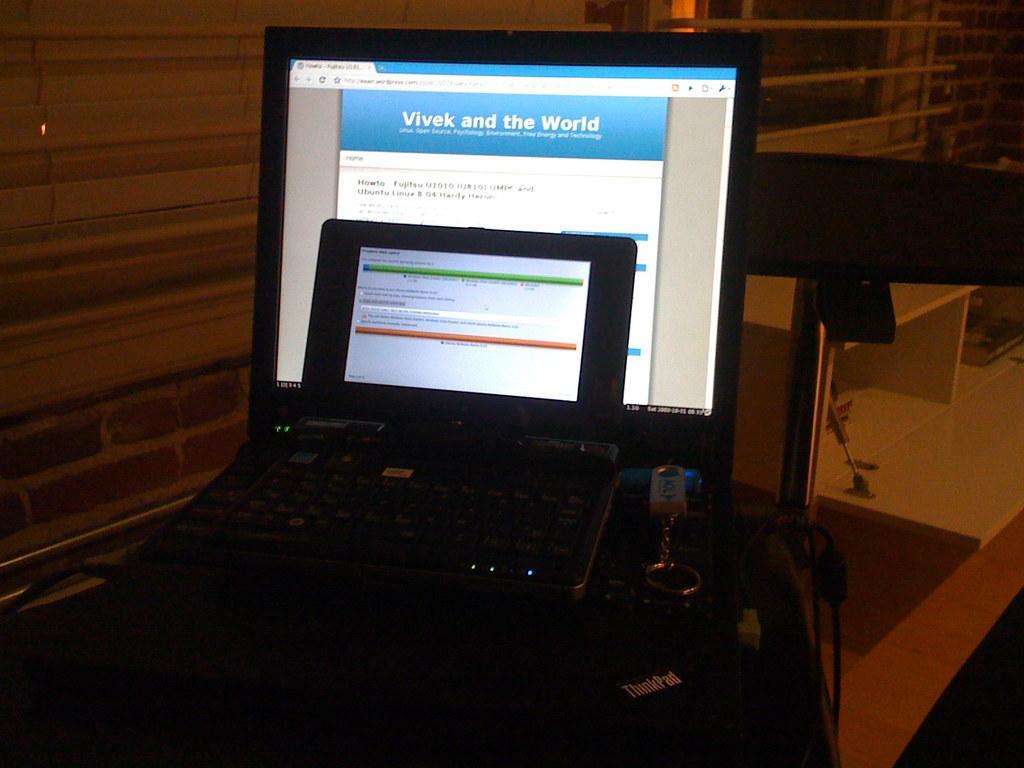In one or two sentences, can you explain what this image depicts? In this picture I can see the laptops in the middle and a key chain, on the right side there are shelves. 